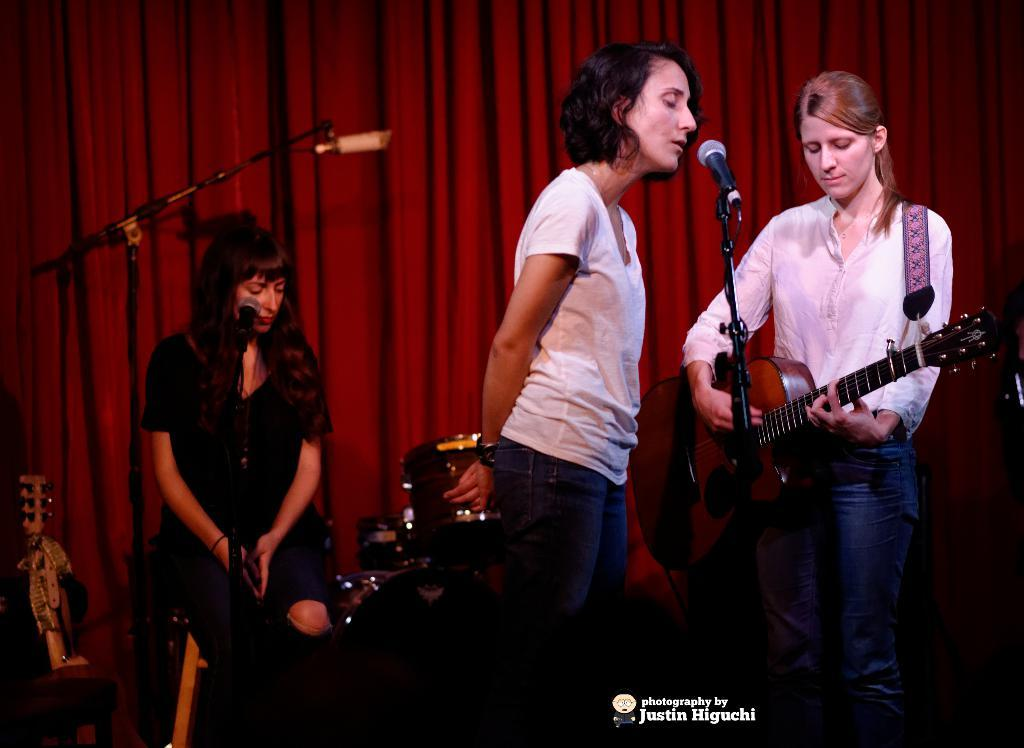What is the main activity of the woman in the image? The woman in the image is standing and playing guitar. How many women are present in the image? There are three women in the image. What is the position of the third woman in the image? The third woman is sitting in the background of the image. What musical instrument can be seen in the image besides the guitar? There are drums visible in the image. What type of creature is causing the engine to malfunction in the image? There is no engine or creature present in the image; it features women playing musical instruments. 